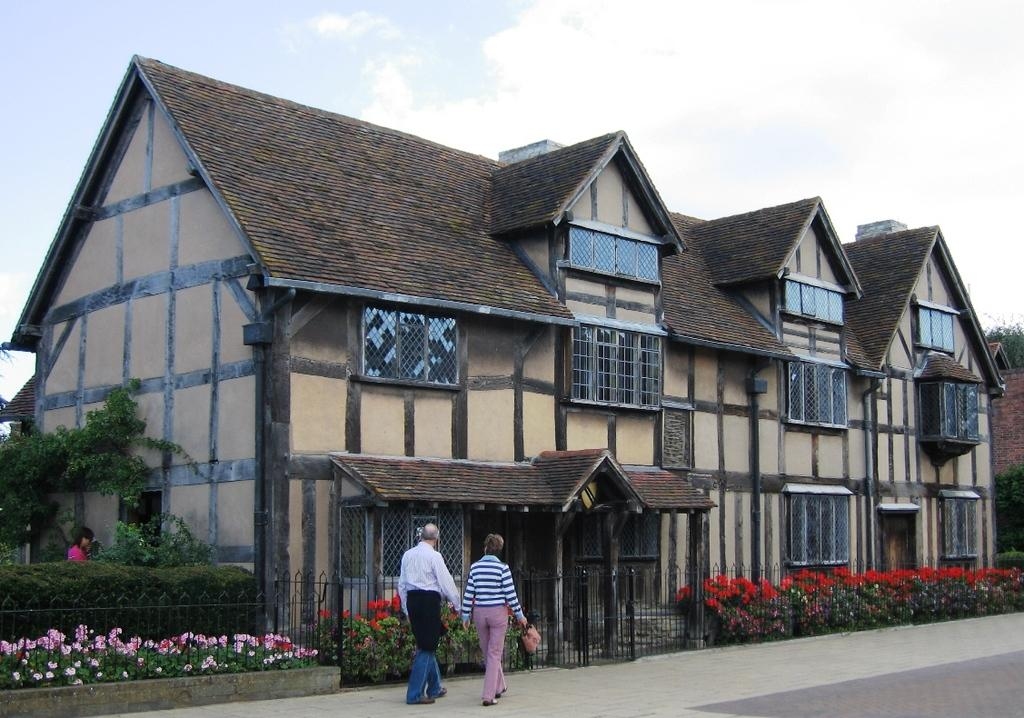What are the two people in the image doing? The two people in the image are walking. Where are the people walking? The people are walking on a walkway. What can be seen on the left side of the image? There is a building on the left side of the image. What type of vegetation is present in the image? There are plants with flowers in the image. What is the condition of the sky in the image? The sky is clear in the image. What type of chain is being used by the army in the image? There is no army or chain present in the image. What historical event is depicted in the image? There is no historical event depicted in the image; it shows two people walking on a walkway. 